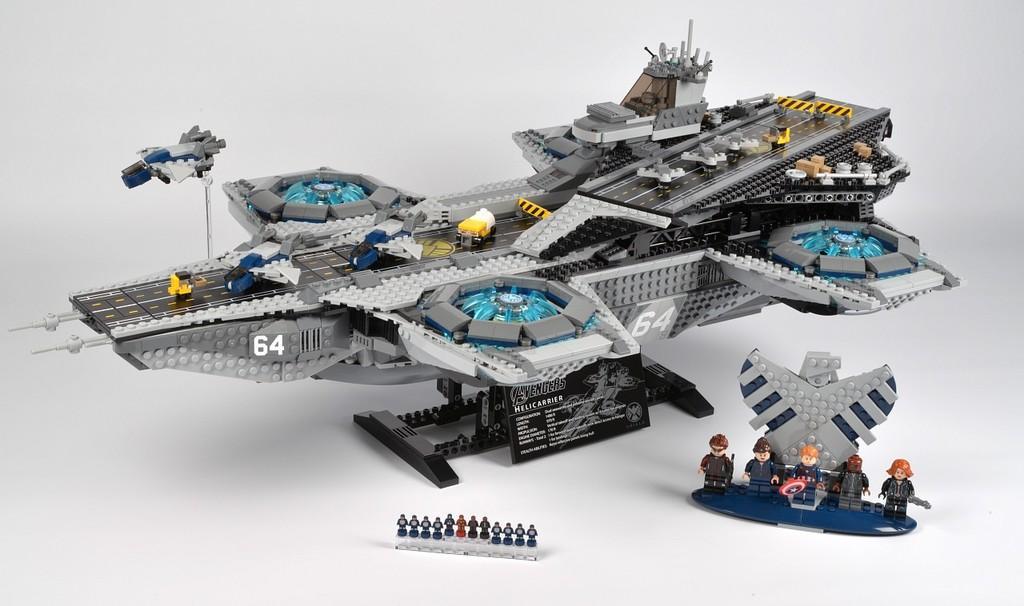Please provide a concise description of this image. In the picture there is a remote control gadget, it has various different parts. 